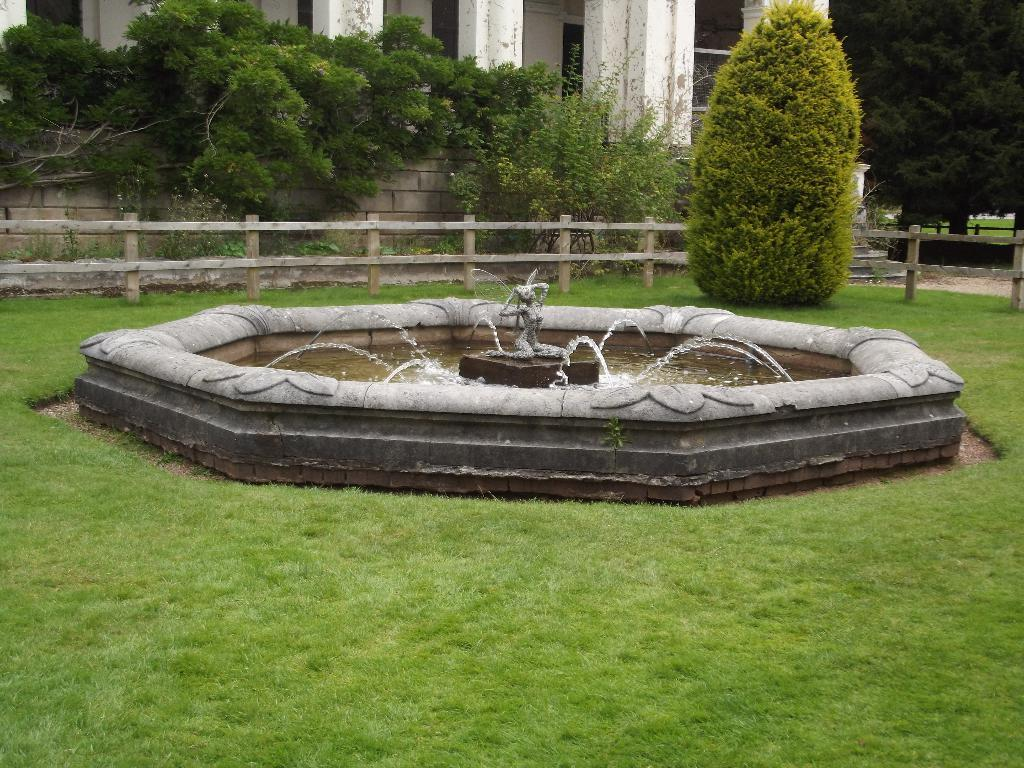What is the main feature in the image? There is a fountain in the image. What surrounds the fountain? There is a garden around the fountain. What can be seen in the background of the image? There is fencing, trees, and a building in the background of the image. What type of silk is being used to order the fountain in the image? There is no silk or order present in the image; it is a fountain surrounded by a garden and situated in front of a building and fencing. 